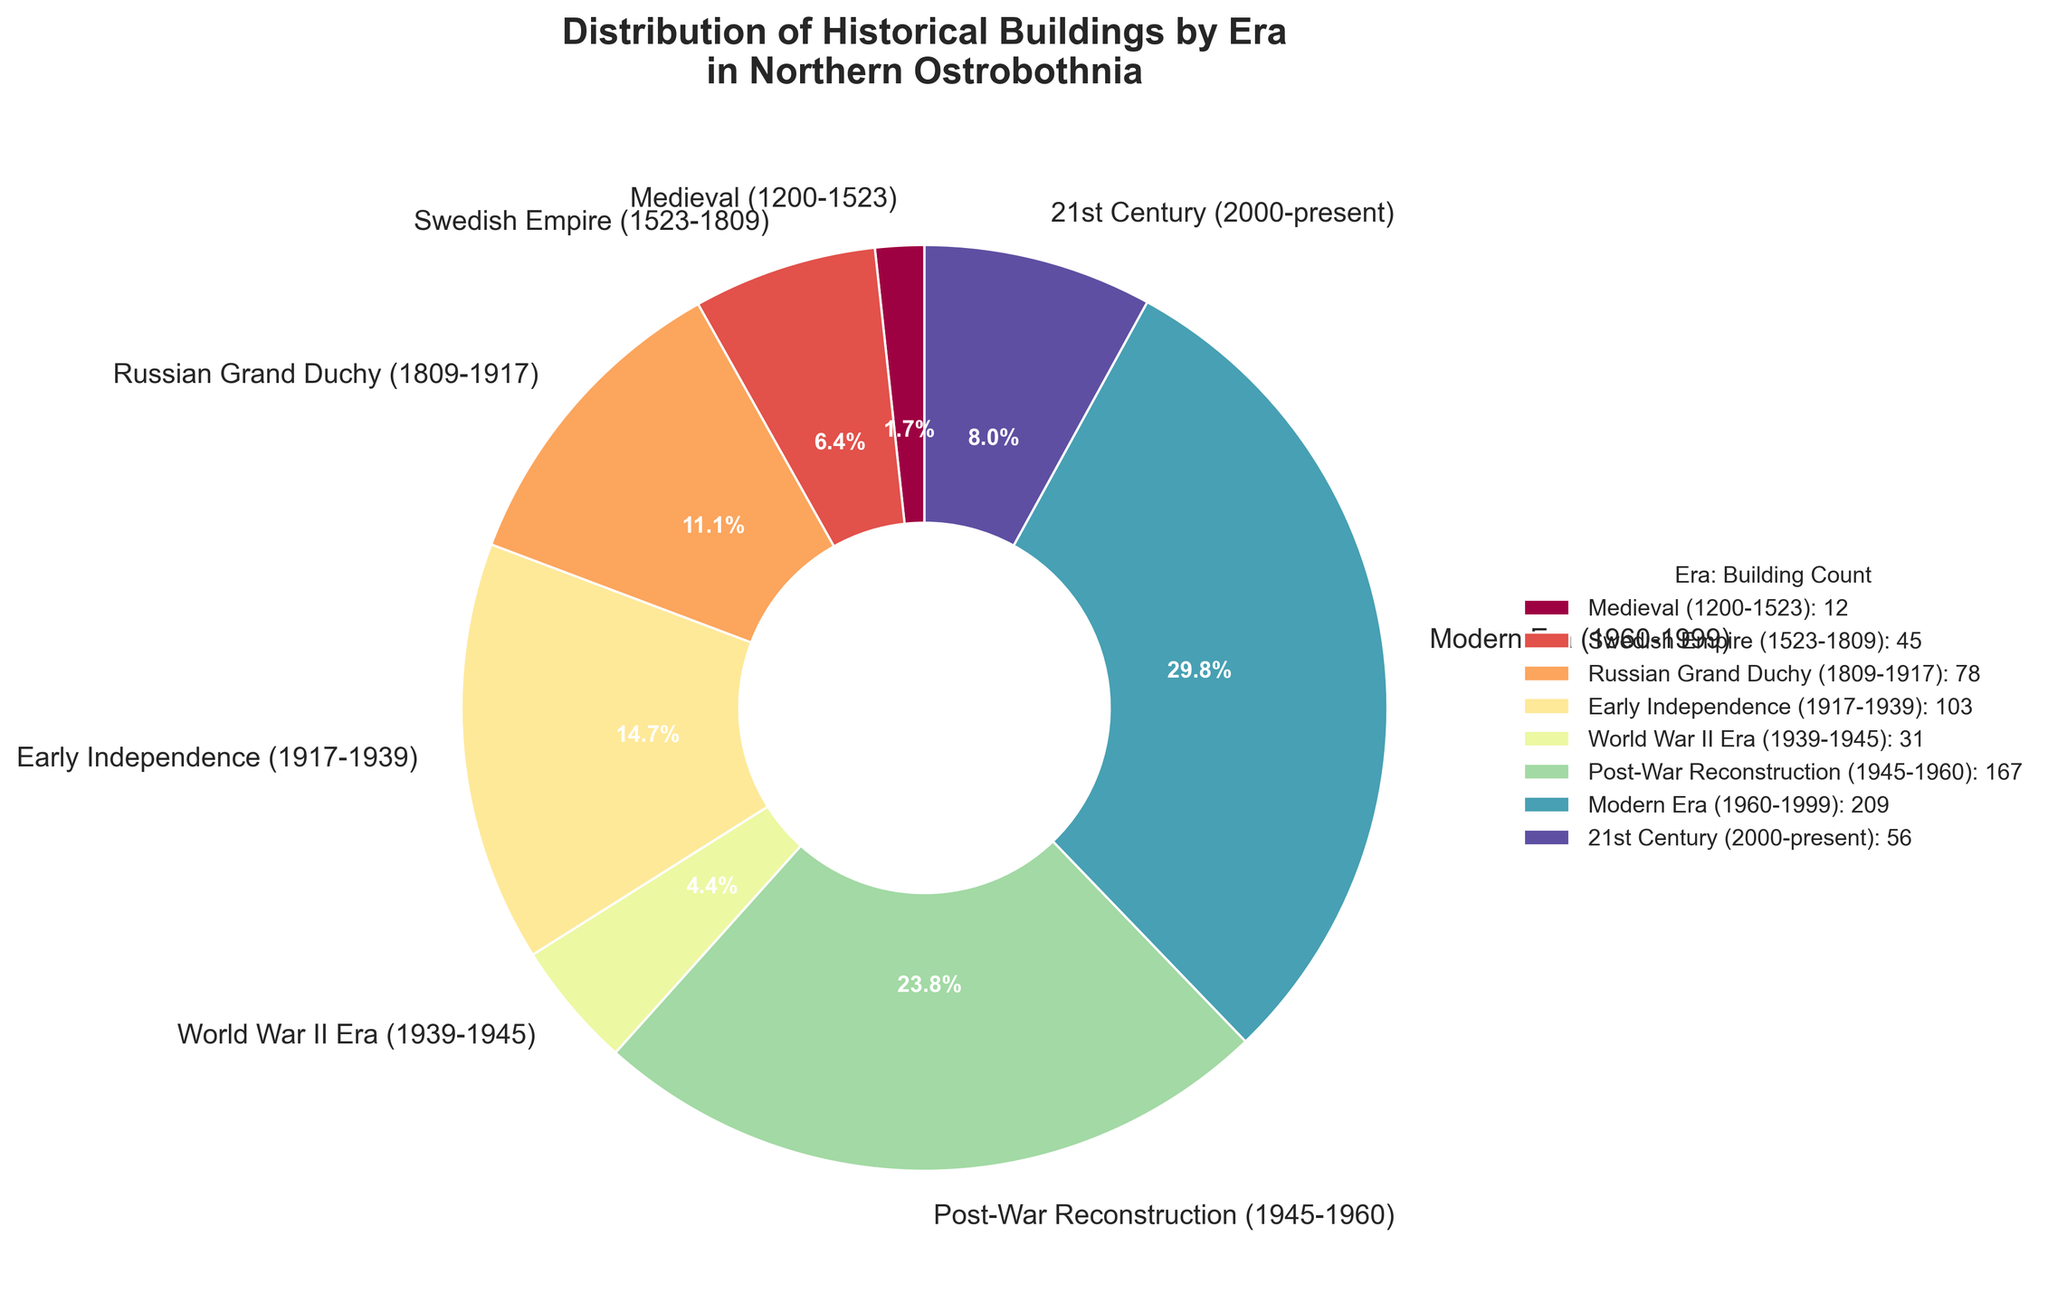What era has the highest number of historical buildings in Northern Ostrobothnia? Observe the pie chart and identify which era has the largest segment. The largest segment corresponds to the Modern Era (1960-1999).
Answer: Modern Era (1960-1999) Which two eras combined account for the most historical buildings? Identify the two largest segments in the pie chart, which are the Modern Era (1960-1999) and the Post-War Reconstruction (1945-1960). Add their numbers together: 209 (Modern Era) + 167 (Post-War Reconstruction) = 376.
Answer: Modern Era and Post-War Reconstruction What is the percentage of buildings from the Early Independence and World War II eras combined? Add the numbers of buildings from the Early Independence (103) and World War II (31) eras, then calculate their combined percentage of the total: (103 + 31) / Total buildings * 100 = 134 / 701 * 100 ≈ 19.1%.
Answer: Approximately 19.1% Which era has the smallest representation of buildings? Observe the pie chart and identify the smallest segment, which corresponds to the Medieval (1200-1523) era.
Answer: Medieval (1200-1523) How many more buildings are from the Post-War Reconstruction era compared to the World War II era? Subtract the number of buildings from the World War II era (31) from the Post-War Reconstruction era (167): 167 - 31 = 136.
Answer: 136 Which eras have a building count greater than 100? Identify the segments with more than 100 buildings: the Early Independence (103), Post-War Reconstruction (167), and Modern Era (209).
Answer: Early Independence, Post-War Reconstruction, and Modern Era What is the ratio of buildings from the Russian Grand Duchy era compared to the Swedish Empire era? Compare the numbers: Russian Grand Duchy (78) and Swedish Empire (45). The ratio is 78:45, which simplifies to approximately 1.73:1.
Answer: 1.73:1 How does the number of buildings from the 21st Century compare to the World War II era? Observe the pie chart and compare the 21st Century (56) with the World War II era (31). The 21st Century has 56 - 31 = 25 more buildings.
Answer: 25 more What percentage of buildings are from eras prior to the Early Independence era? Sum the buildings from earlier eras: Medieval (12) + Swedish Empire (45) + Russian Grand Duchy (78) = 135. Calculate the percentage of the total: 135 / 701 * 100 ≈ 19.3%.
Answer: Approximately 19.3% What is the difference in the percentage of buildings between the Early Independence and Modern Era? Calculate the percentages: Early Independence is 103 / 701 * 100 ≈ 14.7%, Modern Era is 209 / 701 * 100 ≈ 29.8%. The difference is 29.8% - 14.7% = 15.1%.
Answer: 15.1% 